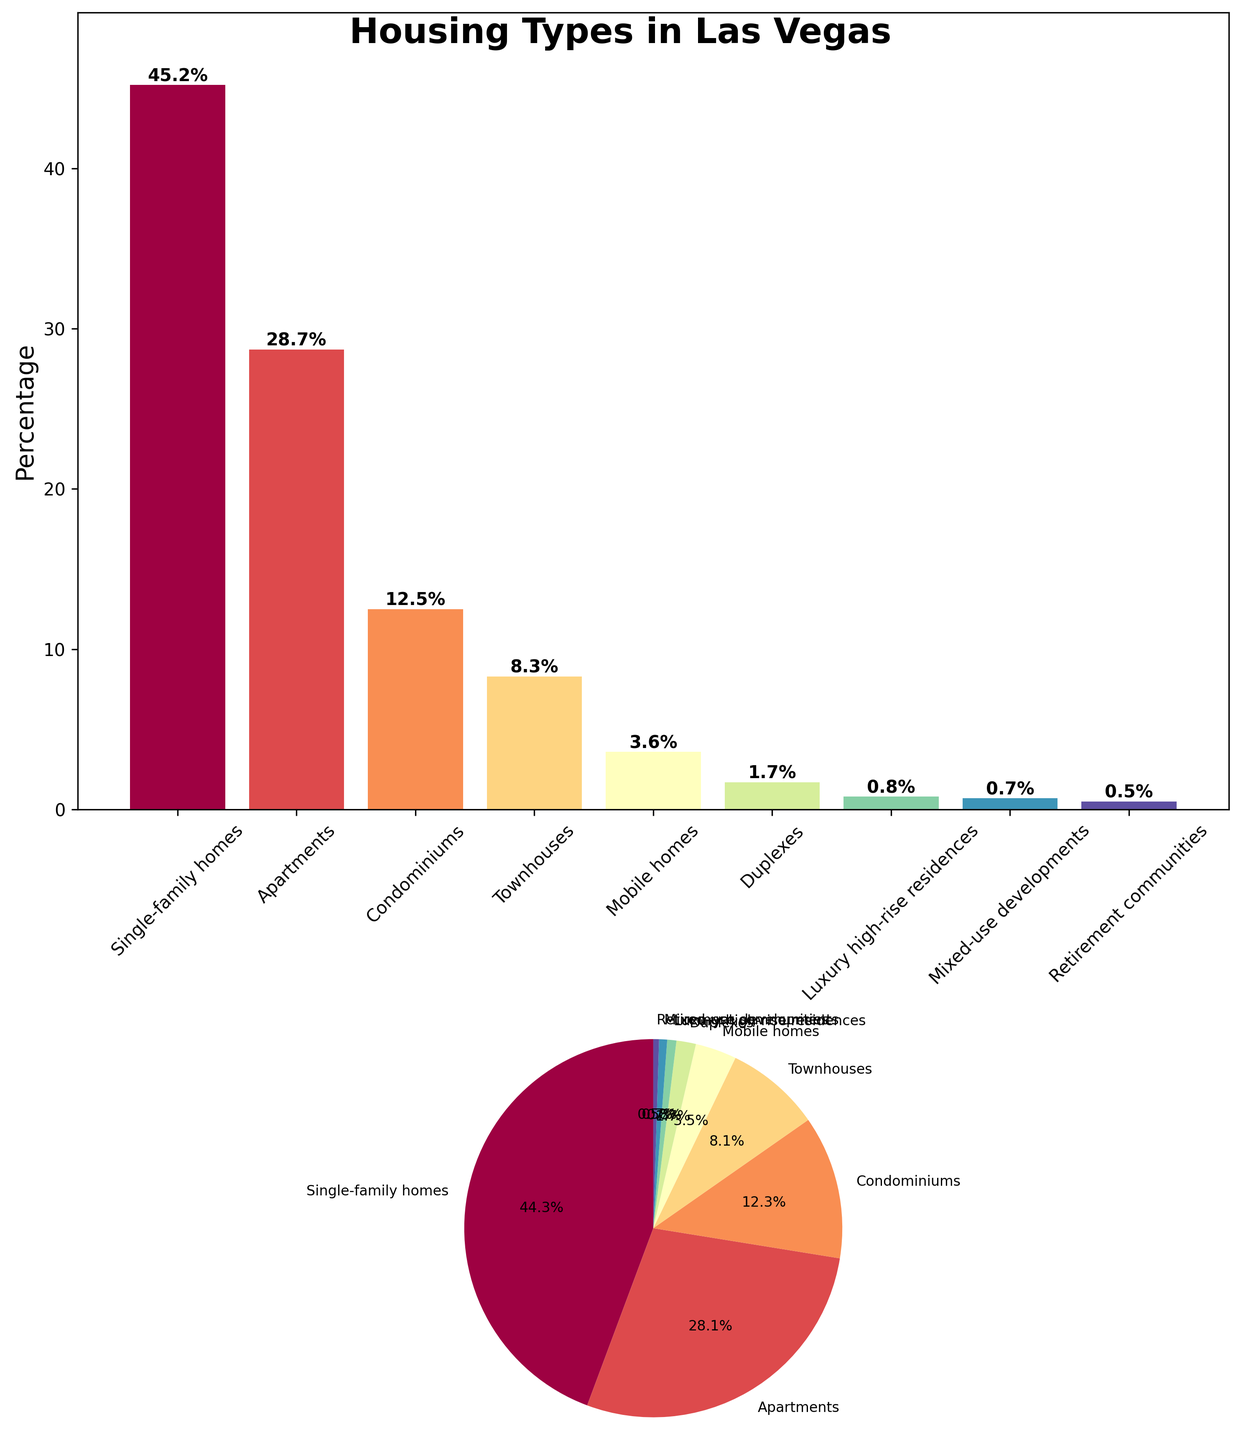what is the housing type with the highest percentage? The bar plot shows that Single-family homes have the highest bar height and the pie chart also shows the largest segment for Single-family homes.
Answer: Single-family homes How do single-family homes compare to apartments in terms of percentage? From the bar plot, the Single-family homes have a higher percentage bar than Apartments. Similarly, in the pie chart, the segment for Single-family homes is larger compared to Apartments. This indicates that Single-family homes have a higher percentage than Apartments. The exact percentages are 45.2% for Single-family homes and 28.7% for Apartments.
Answer: Single-family homes have a higher percentage What percentage of housing types have a percentage of less than 5%? By scanning the bar plot and verifying with the pie chart, we identify Mobile homes (3.6%), Duplexes (1.7%), Luxury high-rise residences (0.8%), Mixed-use developments (0.7%), and Retirement communities (0.5%) all have percentages below 5%.
Answer: 5 housing types What's the combined percentage of Townhouses and Condominiums? From the bar plot and confirming with the pie chart, the percentages for Townhouses and Condominiums are 8.3% and 12.5% respectively. Summing these values gives 8.3 + 12.5 = 20.8%.
Answer: 20.8% Which housing type has the smallest percentage, and what is it? By looking at both the bar plot and pie chart, Retirement communities have the smallest bar and pie segment. The percentage is indicated as 0.5%.
Answer: Retirement communities, 0.5% By how much does the second highest housing type's percentage differ from the highest? The highest percentage housing type is Single-family homes at 45.2% and the second highest is Apartments at 28.7%. The difference is calculated as 45.2 - 28.7 = 16.5%.
Answer: 16.5% Which two housing types together make up more than 50% of the total housing types? Examining the bar plot and pie chart reveals that Single-family homes (45.2%) alone are not enough. Adding the next highest, Apartments (28.7%), the combined proportion becomes 45.2 + 28.7 = 73.9%, which is more than 50%.
Answer: Single-family homes and Apartments How many housing types have percentages greater than 10%? From both the bar plot and pie chart, we see Single-family homes, Apartments, and Condominiums each have percentages greater than 10% (45.2%, 28.7%, and 12.5% respectively).
Answer: 3 housing types What's the total percentage of housing types including Mixed-use developments, Retirement communities, and Luxury high-rise residences? The bar plot and pie chart show percentages as follows: Mixed-use developments (0.7%), Retirement communities (0.5%), and Luxury high-rise residences (0.8%). Adding these up gives 0.7 + 0.5 + 0.8 = 2.0%.
Answer: 2.0% How does the representation of Duplexes in the pie chart relate to that of Mobile homes? Looking at the pie chart, the segment for Duplexes (1.7%) is markedly smaller than that for Mobile homes (3.6%), showing that the percentage for Duplexes is lower.
Answer: Duplexes have a lower percentage 